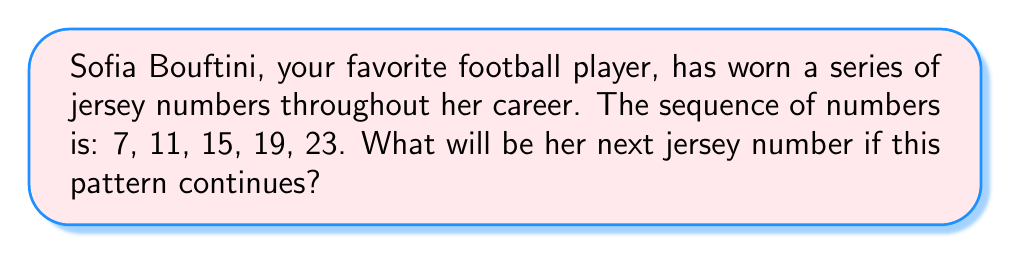Help me with this question. To solve this problem, let's analyze the pattern in the given sequence:

1) First, let's look at the differences between consecutive terms:
   $11 - 7 = 4$
   $15 - 11 = 4$
   $19 - 15 = 4$
   $23 - 19 = 4$

2) We can see that the difference between each consecutive term is consistently 4.

3) We can express this sequence mathematically as an arithmetic sequence:
   $a_n = a_1 + (n-1)d$
   Where $a_n$ is the nth term, $a_1$ is the first term, $n$ is the position of the term, and $d$ is the common difference.

4) In this case:
   $a_1 = 7$ (first term)
   $d = 4$ (common difference)

5) To find the next number, we need to find the 6th term (as we're given 5 terms already):
   $a_6 = a_1 + (6-1)d$
   $a_6 = 7 + (5)(4)$
   $a_6 = 7 + 20$
   $a_6 = 27$

Therefore, if the pattern continues, Sofia Bouftini's next jersey number will be 27.
Answer: 27 